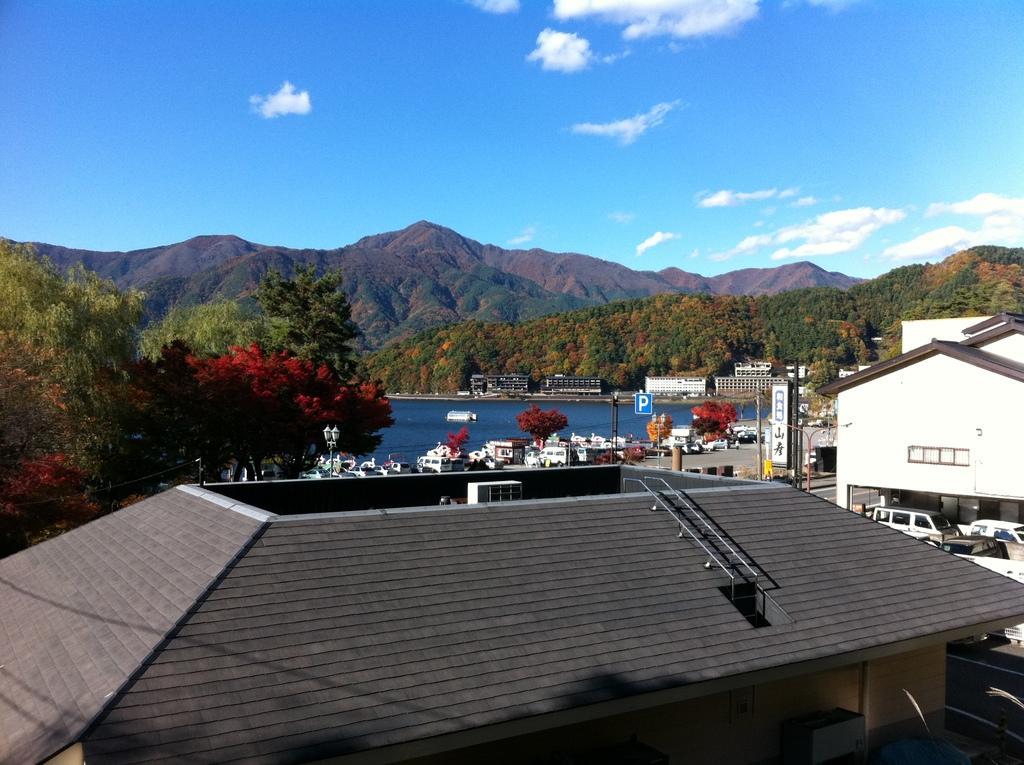Describe this image in one or two sentences. In this picture we can see buildings, trees, poles, boards and water. In the background of the image we can see hills and sky with clouds. 